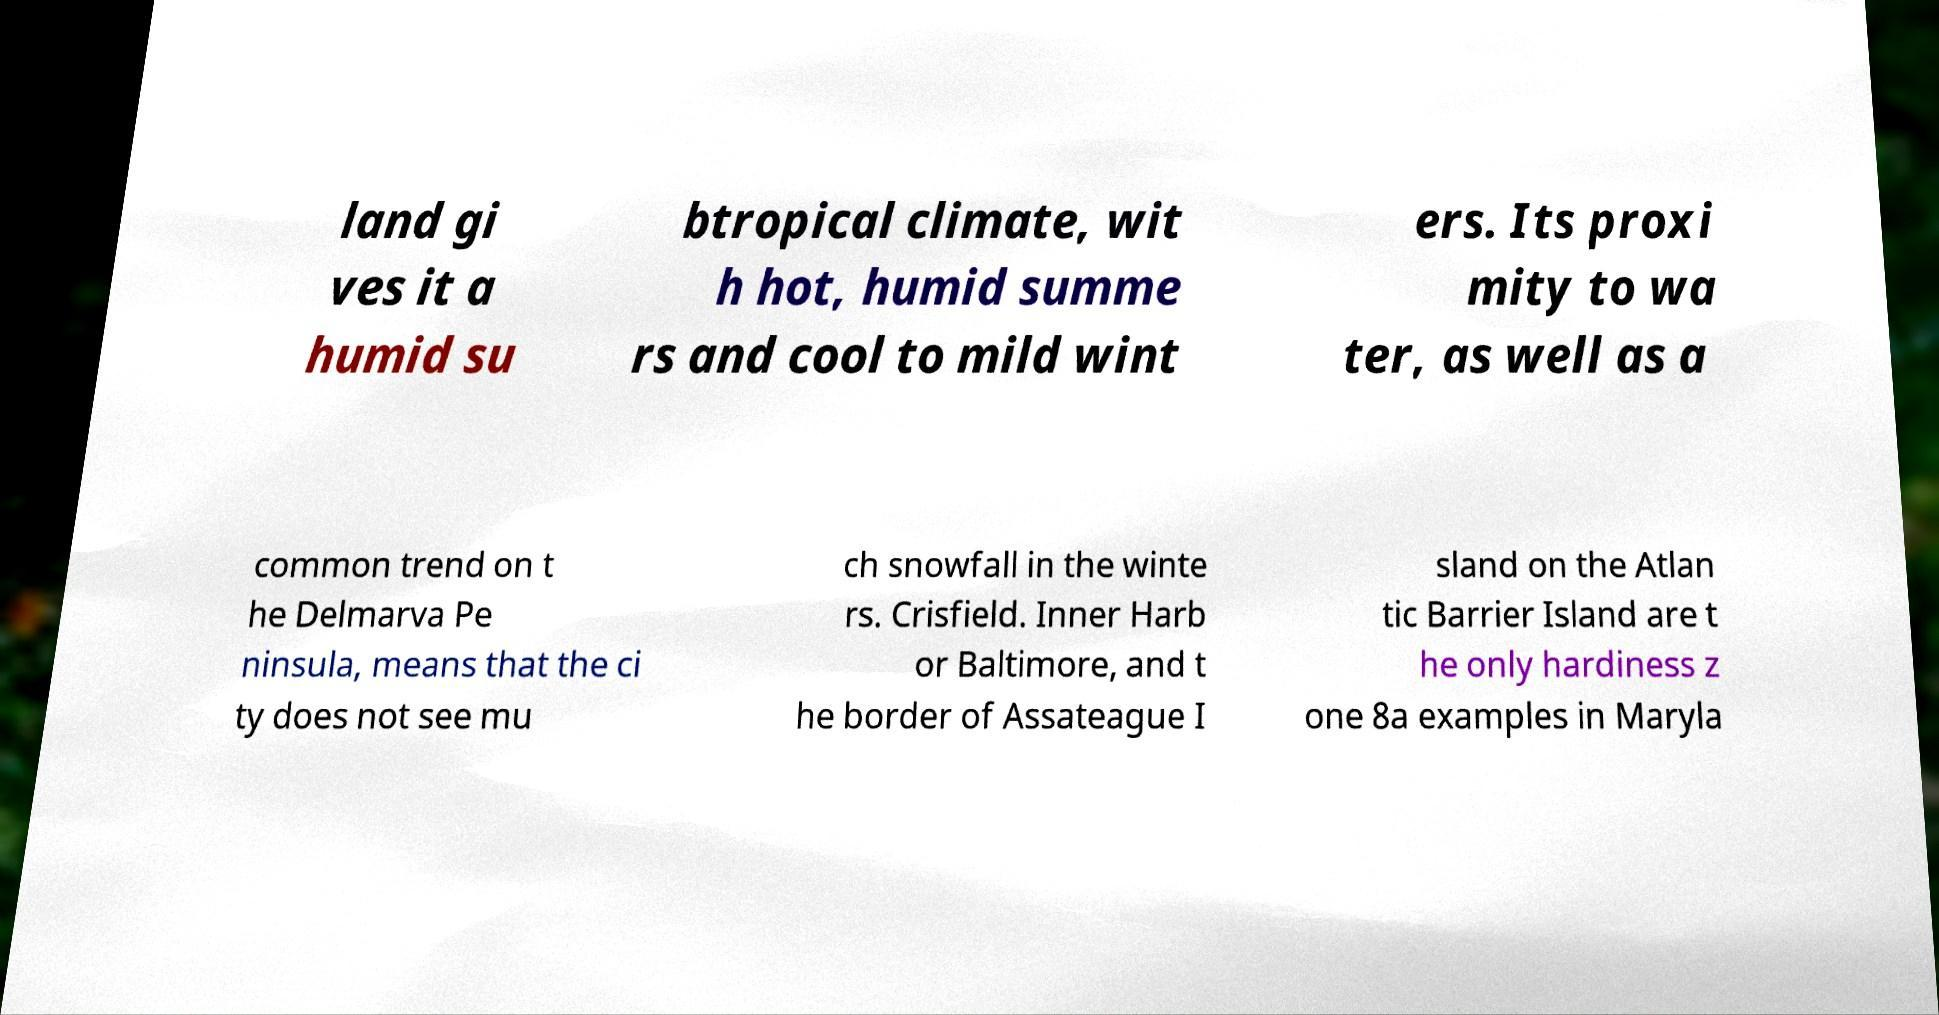Can you accurately transcribe the text from the provided image for me? land gi ves it a humid su btropical climate, wit h hot, humid summe rs and cool to mild wint ers. Its proxi mity to wa ter, as well as a common trend on t he Delmarva Pe ninsula, means that the ci ty does not see mu ch snowfall in the winte rs. Crisfield. Inner Harb or Baltimore, and t he border of Assateague I sland on the Atlan tic Barrier Island are t he only hardiness z one 8a examples in Maryla 